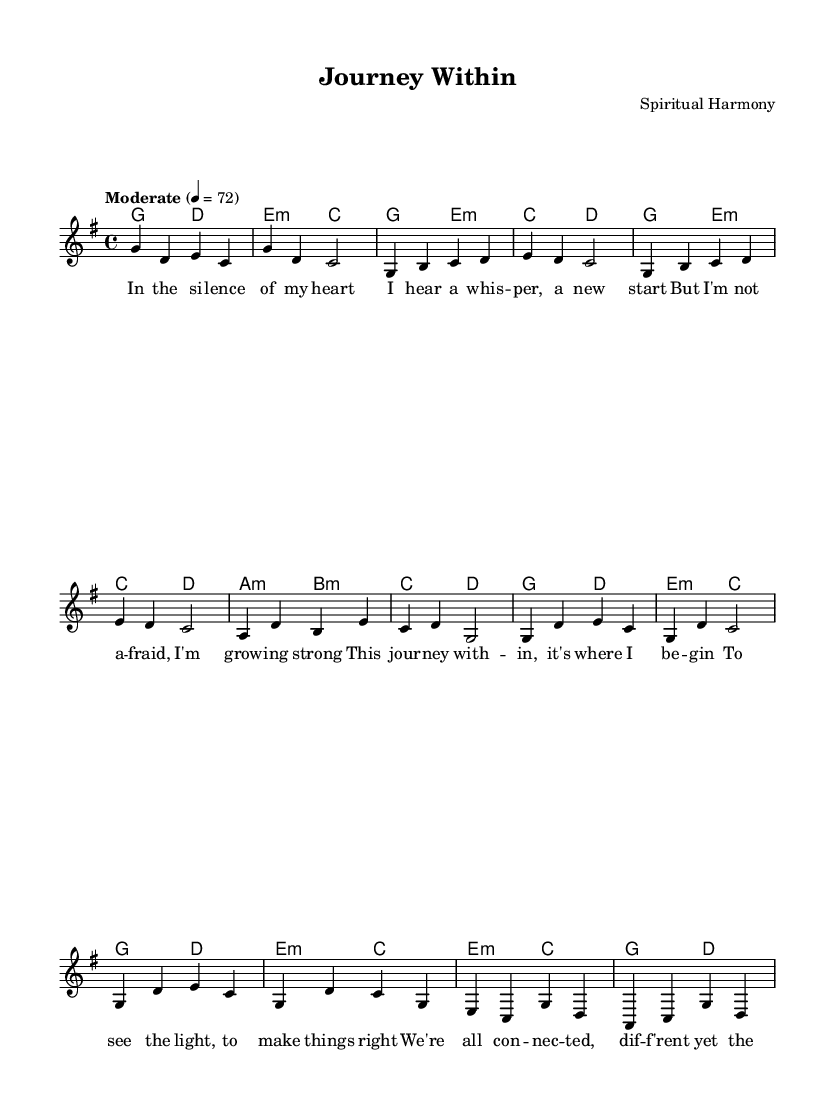What is the key signature of this music? The key signature is G major, which has one sharp (F#). You can determine the key signature by looking at the beginning of the music where the note changes reflect the F# sharp.
Answer: G major What is the time signature of this music? The time signature is four-four, indicated by the "4/4" notation in the music. This means there are four beats in each measure and the quarter note gets one beat.
Answer: Four-four What is the tempo marking of this piece? The tempo marking is "Moderate" with a beat of 72 per minute, indicated in the tempo direction at the beginning of the score.
Answer: Moderate How many phrases are in the chorus? The chorus consists of two phrases as repeated lines can be seen in the sheet music structure, each with a similar melodic shape.
Answer: Two What is the first lyric line of the verse? The first lyric line of the verse is "In the silence of my heart," as indicated directly under the melody staff where the lyrics align with the corresponding notes.
Answer: In the silence of my heart What chords begin the bridge section? The chords that begin the bridge section are E minor and C major, shown at the start of this segment in the harmonies part of the sheet music.
Answer: E minor, C major How many times is the pre-chorus stated before returning to the chorus? The pre-chorus is stated once before returning to the chorus, as demonstrated by the progression from the pre-chorus chords to the chorus indication.
Answer: Once 